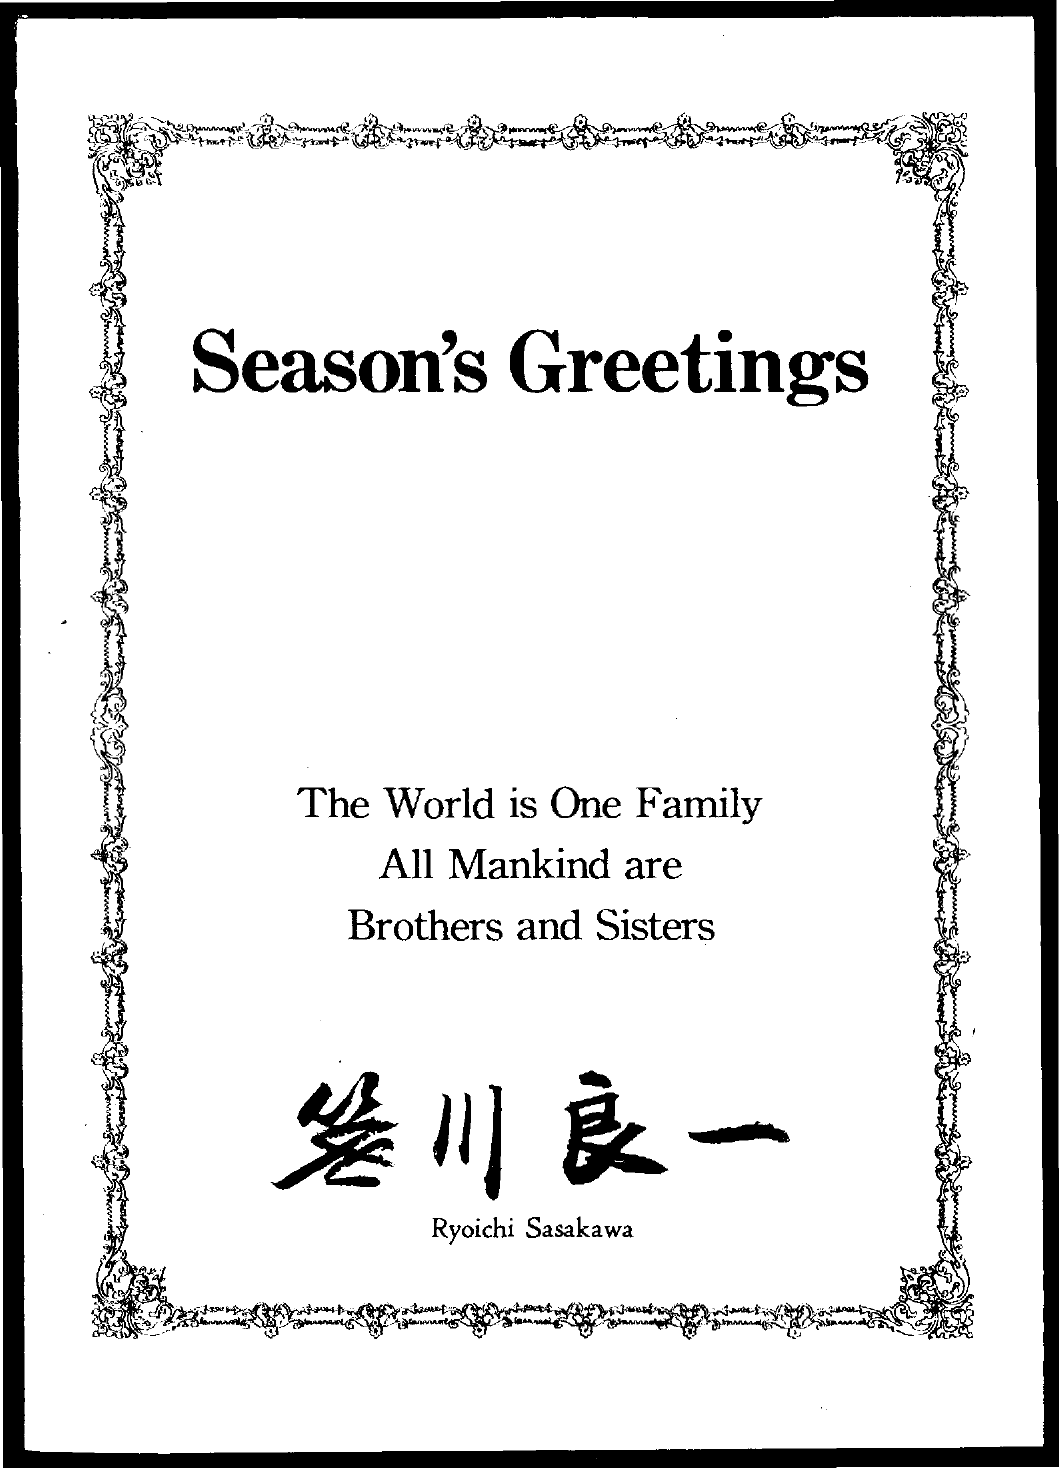What is the title of the document?
Your response must be concise. Season's Greetings. 